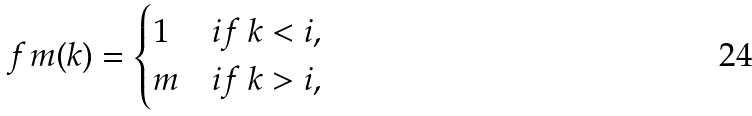Convert formula to latex. <formula><loc_0><loc_0><loc_500><loc_500>f _ { \ } m ( k ) = \begin{cases} 1 & i f \ k < i , \\ m & i f \ k > i , \end{cases}</formula> 